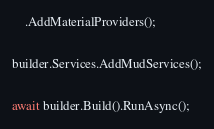<code> <loc_0><loc_0><loc_500><loc_500><_C#_>    .AddMaterialProviders();

builder.Services.AddMudServices();

await builder.Build().RunAsync();

</code> 